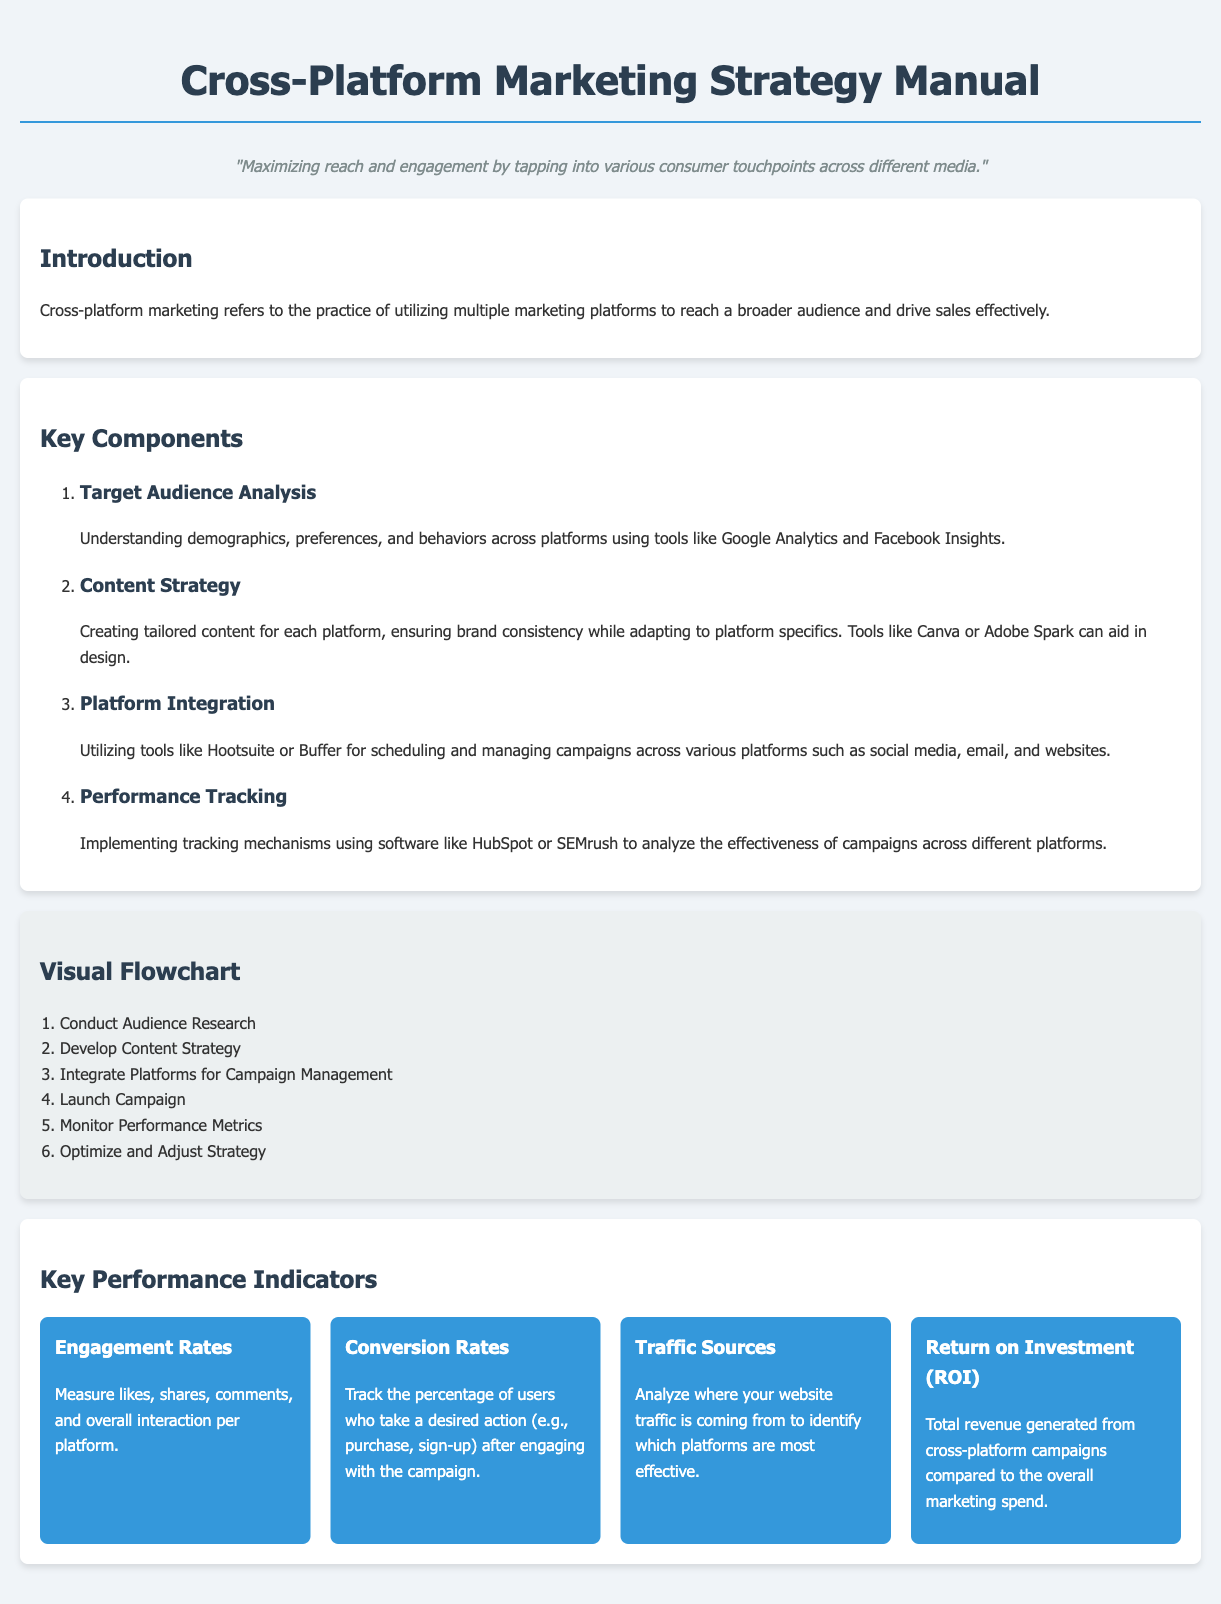What is the title of the document? The title of the document is the main heading that introduces the content about marketing strategies.
Answer: Cross-Platform Marketing Strategy Manual What does cross-platform marketing aim to achieve? This refers to the overarching goal stated in the introduction of the document.
Answer: Reach a broader audience and drive sales effectively What is the first component of the key components section? The first component mentioned outlines the fundamental area of focus in cross-platform marketing.
Answer: Target Audience Analysis Which tool is suggested for scheduling campaigns? This tool is recommended for integrating and managing campaigns across platforms.
Answer: Hootsuite What metric is used to measure user interactions on platforms? This key performance indicator helps in understanding how users engage with the content.
Answer: Engagement Rates How many steps are in the visual flowchart? This number indicates the total steps involved in the process described in the flowchart section.
Answer: Six steps What is the primary use of HubSpot in the marketing strategy? This software functions within the performance tracking component of the cross-platform marketing strategy.
Answer: Analyze the effectiveness of campaigns What is the KPI focused on revenue generation? This key performance indicator evaluates financial performance in relation to marketing spend.
Answer: Return on Investment (ROI) 